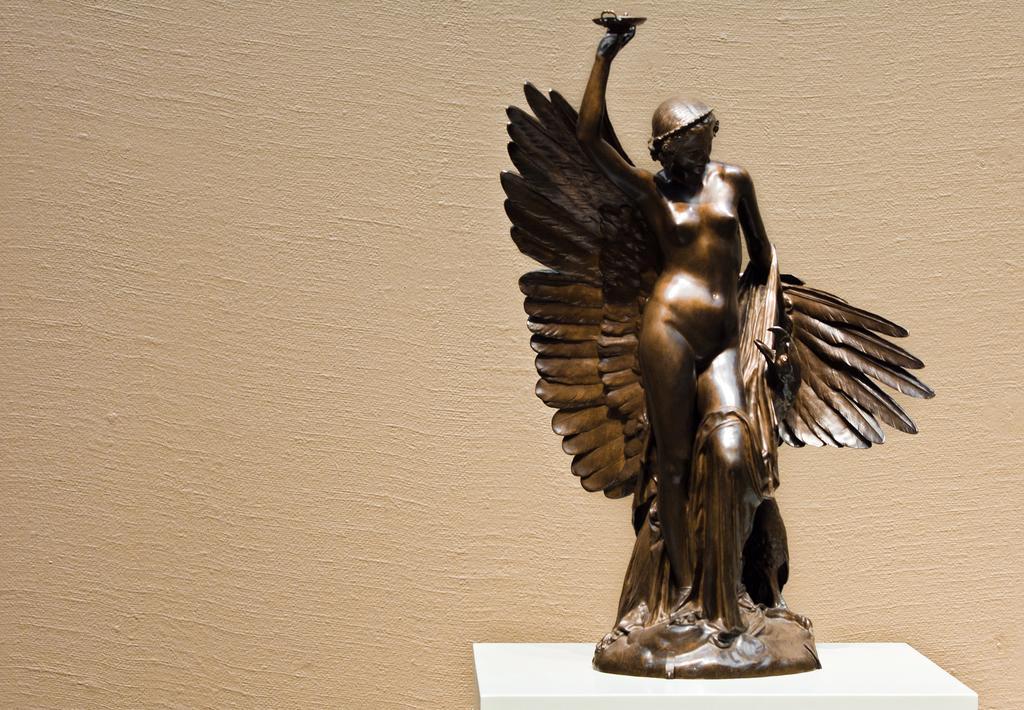Could you give a brief overview of what you see in this image? In this image there is a lady statue on the white table. In the background there is a wall. 